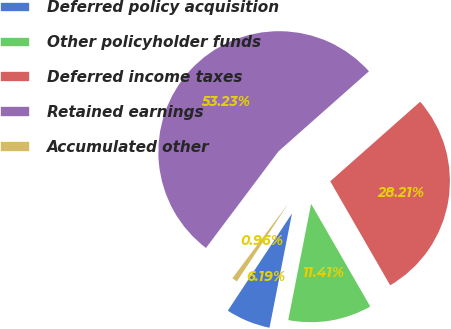<chart> <loc_0><loc_0><loc_500><loc_500><pie_chart><fcel>Deferred policy acquisition<fcel>Other policyholder funds<fcel>Deferred income taxes<fcel>Retained earnings<fcel>Accumulated other<nl><fcel>6.19%<fcel>11.41%<fcel>28.21%<fcel>53.22%<fcel>0.96%<nl></chart> 